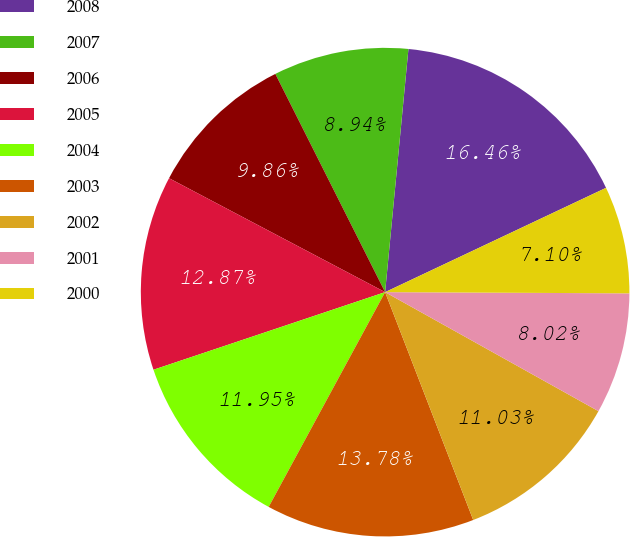Convert chart. <chart><loc_0><loc_0><loc_500><loc_500><pie_chart><fcel>2008<fcel>2007<fcel>2006<fcel>2005<fcel>2004<fcel>2003<fcel>2002<fcel>2001<fcel>2000<nl><fcel>16.46%<fcel>8.94%<fcel>9.86%<fcel>12.87%<fcel>11.95%<fcel>13.78%<fcel>11.03%<fcel>8.02%<fcel>7.1%<nl></chart> 